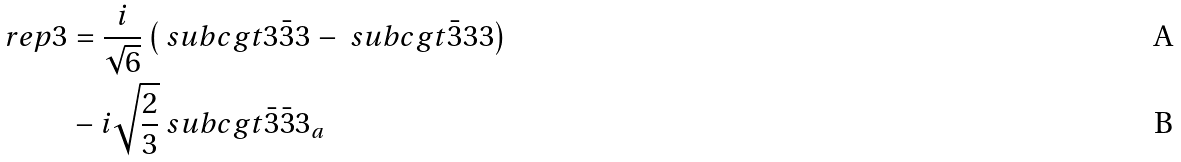Convert formula to latex. <formula><loc_0><loc_0><loc_500><loc_500>\ r e p { 3 } & = \frac { i } { \sqrt { 6 } } \left ( \ s u b c g t { 3 } { \bar { 3 } } { 3 } - \ s u b c g t { \bar { 3 } } { 3 } { 3 } \right ) \\ & - i \sqrt { \frac { 2 } { 3 } } \ s u b c g t { \bar { 3 } } { \bar { 3 } } { 3 _ { a } }</formula> 